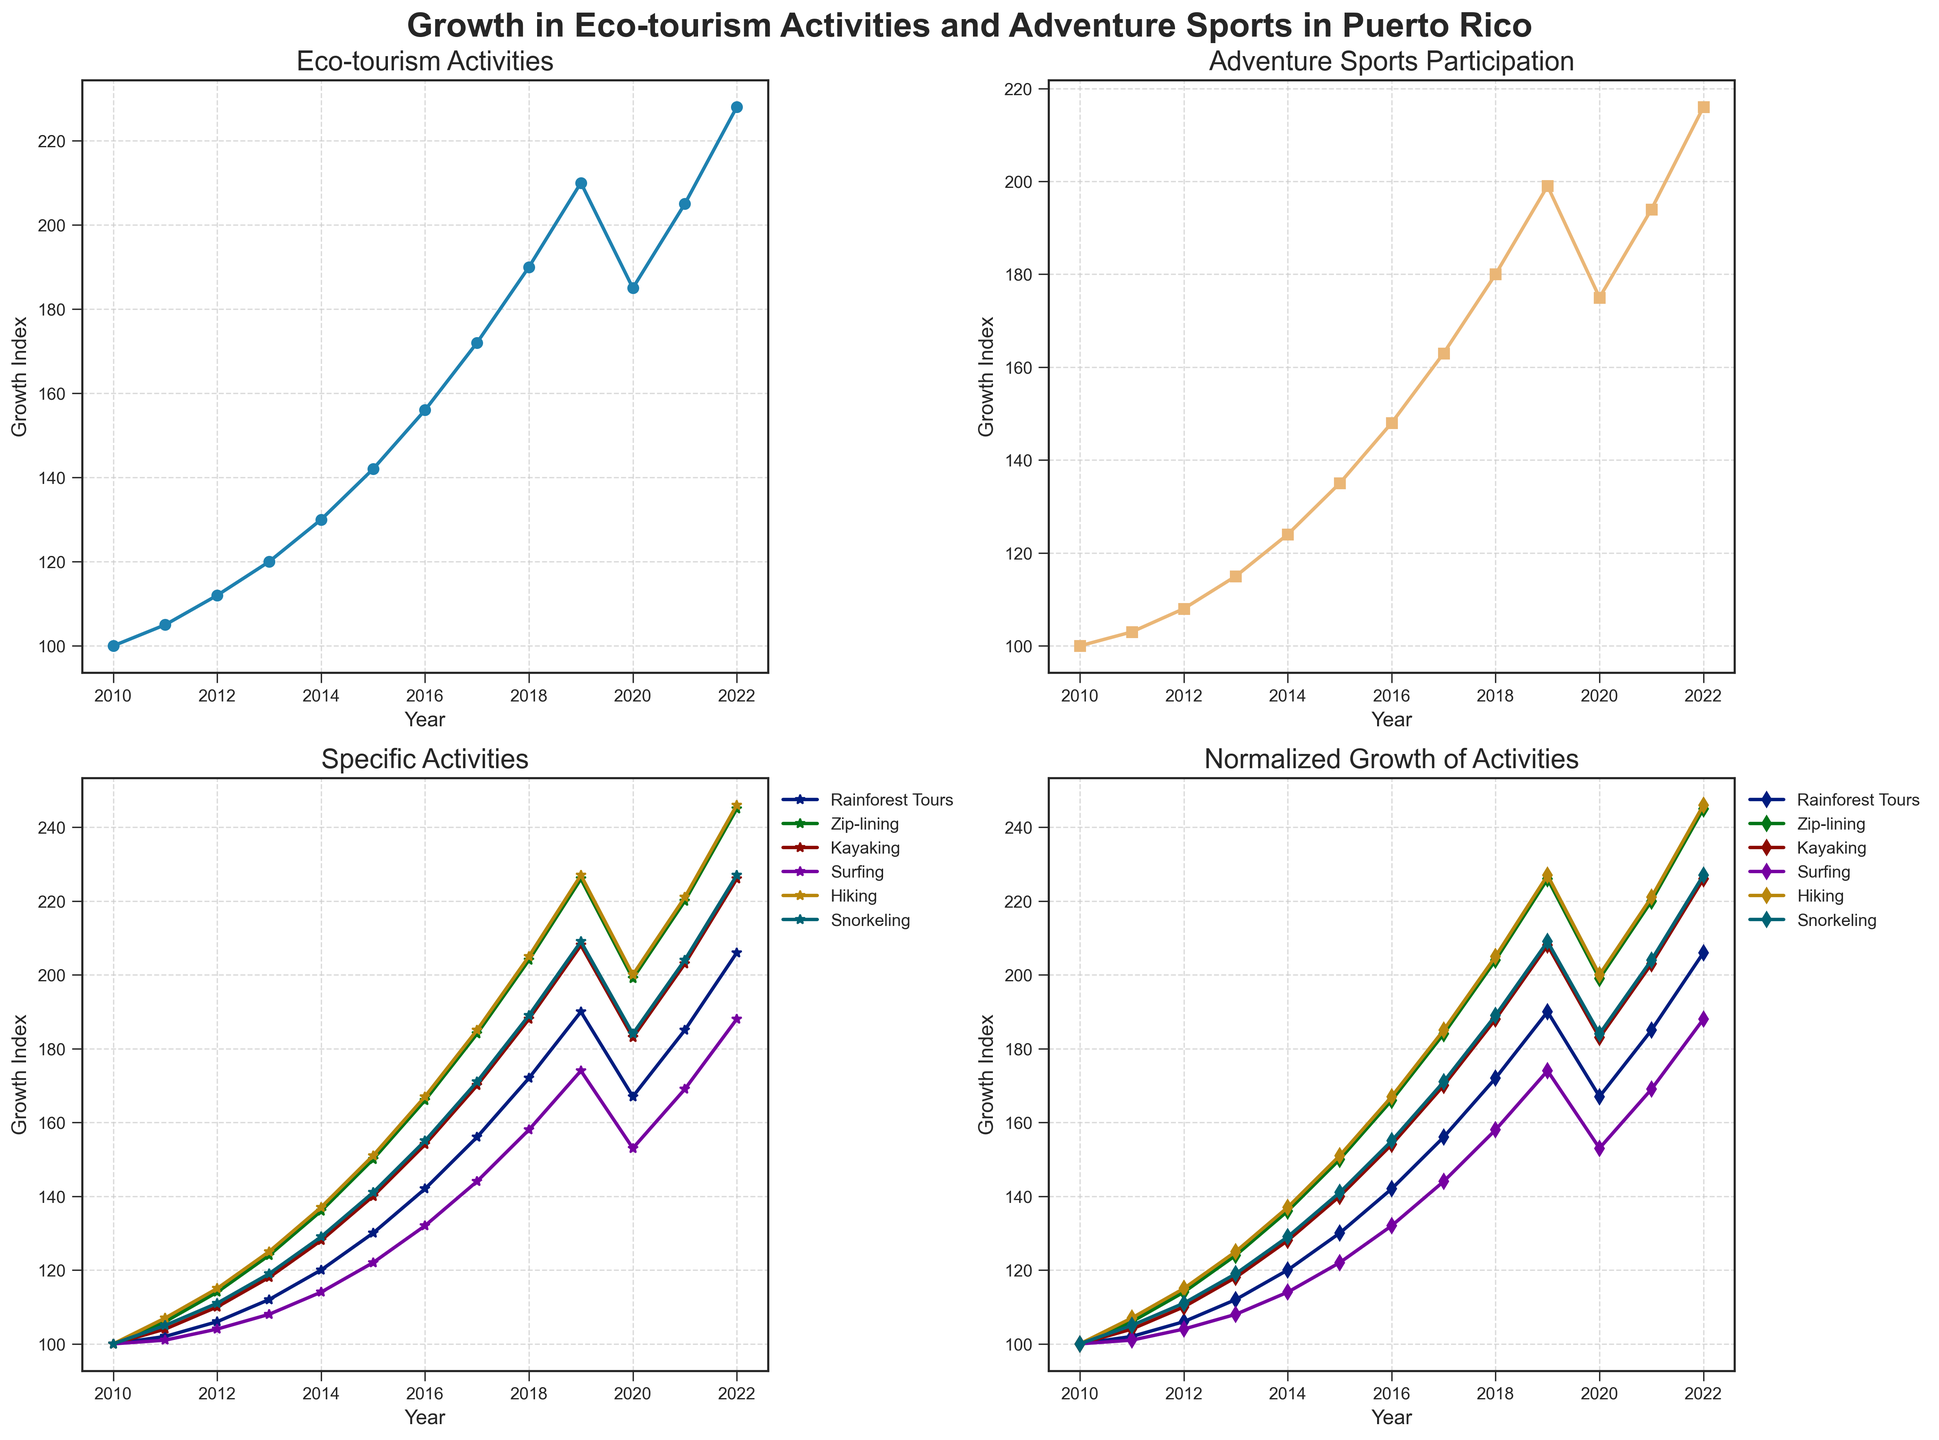What's the overall trend in eco-tourism activities from 2010 to 2022? The line chart for Eco-tourism Activities in the top-left subplot shows a generally upward trend from 2010 to 2022 with a slight dip in 2020, indicating growth in eco-tourism activities over the years.
Answer: Upward trend Which year shows a notable decline in adventure sports participation? The line chart for Adventure Sports Participation in the top-right subplot shows a notable dip around 2020. This reveals that 2020 was a year of decline in adventure sports participation.
Answer: 2020 Compare the growth in Rainforest Tours and Kayaking activities from 2010 to 2022. Which one grew more? In the Specific Activities subplot (bottom-left), the growth of Rainforest Tours and Kayaking can be compared by examining the end values in 2022. Rainforest Tours went from 100 to 206, an increase of 106, while Kayaking grew from 100 to 226, an increase of 126.
Answer: Kayaking Which activity has the highest normalized growth index in 2022? Looking at the Normalized Growth of Activities subplot (bottom-right), the line representing each activity can be compared at the year 2022. The activity with the highest end value is Zip-lining.
Answer: Zip-lining What was the difference in growth index between Snorkeling and Hiking in 2020? In the Specific Activities subplot (bottom-left), the values for Snorkeling and Hiking in 2020 need to be identified. Snorkeling is at 184 and Hiking at 153. The difference is 184 - 153 = 31.
Answer: 31 Which specific activity showed the fastest initial growth from 2010 to 2011? By examining the Specific Activities subplot (bottom-left) for the steepest slope between 2010 to 2011, it can be observed that Zip-lining had the fastest initial growth from 100 to 106.
Answer: Zip-lining How does the growth trend of Surfing compare to Snorkeling from 2010 to 2022? In the Specific Activities subplot (bottom-left), the growth trends of Surfing and Snorkeling can be compared. Both show an upward trend, but Surfing reaches 221 while Snorkeling hits 227 in 2022. Snorkeling has a slightly higher endpoint.
Answer: Snorkeling shows higher growth Which year did both Kayaking and Adventure Sports Participation see the same growth value? In the Specific Activities subplot (bottom-left), tracing the lines for Kayaking and Adventure Sports Participation, they intersect at the growth value of approximately 220 in 2021.
Answer: 2021 Are there any activities that showed a consistent positive growth every year from 2010 to 2022? By examining each line in the Specific Activities subplot (bottom-left), it can be observed that activities such as Rainforest Tours, Zip-lining, and Kayaking show consistently positive growth without any dips from 2010 to 2022.
Answer: Rainforest Tours, Zip-lining, Kayaking What's the combined growth index value for Eco-tourism Activities and Adventure Sports Participation in 2018? Referring to both top-left and top-right subplots for the year 2018, Eco-tourism Activities have a value of 190 and Adventure Sports Participation has 180. The combined value is 190 + 180 = 370.
Answer: 370 